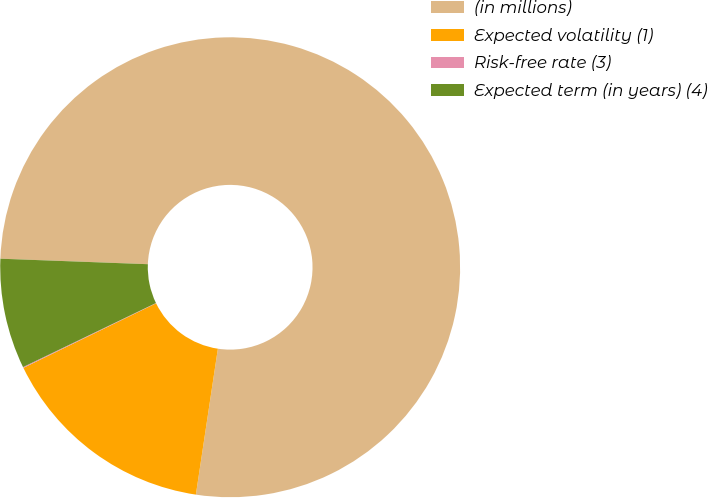Convert chart to OTSL. <chart><loc_0><loc_0><loc_500><loc_500><pie_chart><fcel>(in millions)<fcel>Expected volatility (1)<fcel>Risk-free rate (3)<fcel>Expected term (in years) (4)<nl><fcel>76.79%<fcel>15.41%<fcel>0.06%<fcel>7.74%<nl></chart> 